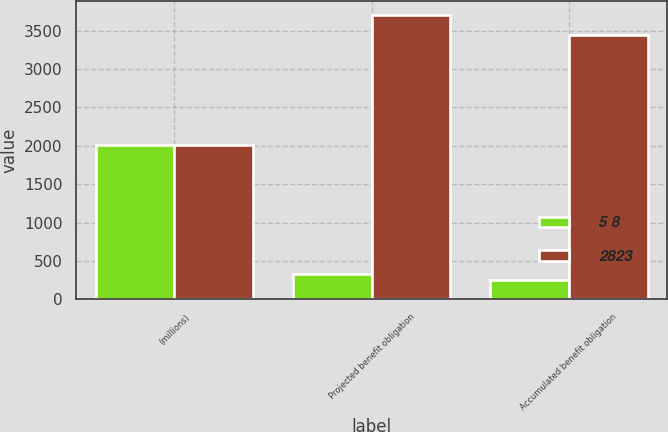<chart> <loc_0><loc_0><loc_500><loc_500><stacked_bar_chart><ecel><fcel>(millions)<fcel>Projected benefit obligation<fcel>Accumulated benefit obligation<nl><fcel>5 8<fcel>2013<fcel>327<fcel>251<nl><fcel>2823<fcel>2012<fcel>3707<fcel>3442<nl></chart> 